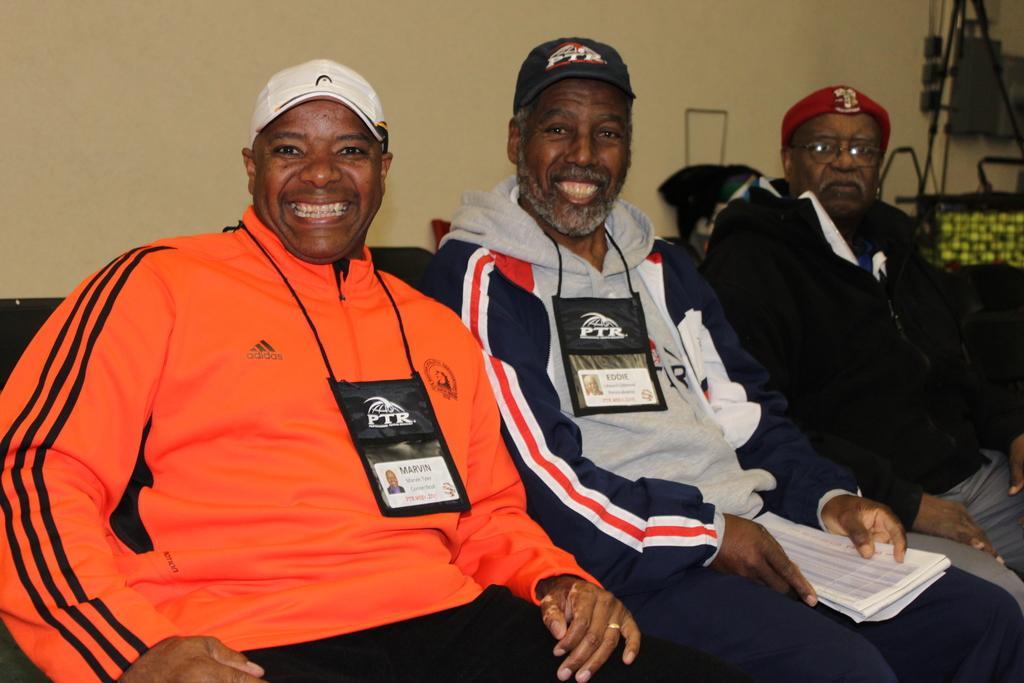Could you give a brief overview of what you see in this image? In this picture, we see three men are sitting on the chairs or on the sofa. The two men are smiling and they are posing for the photo. Behind them, we see a white wall. On the right side, we see a bag in black and yellow color. Beside that, we see a stand. Behind the man, we see a cloth in black color. 